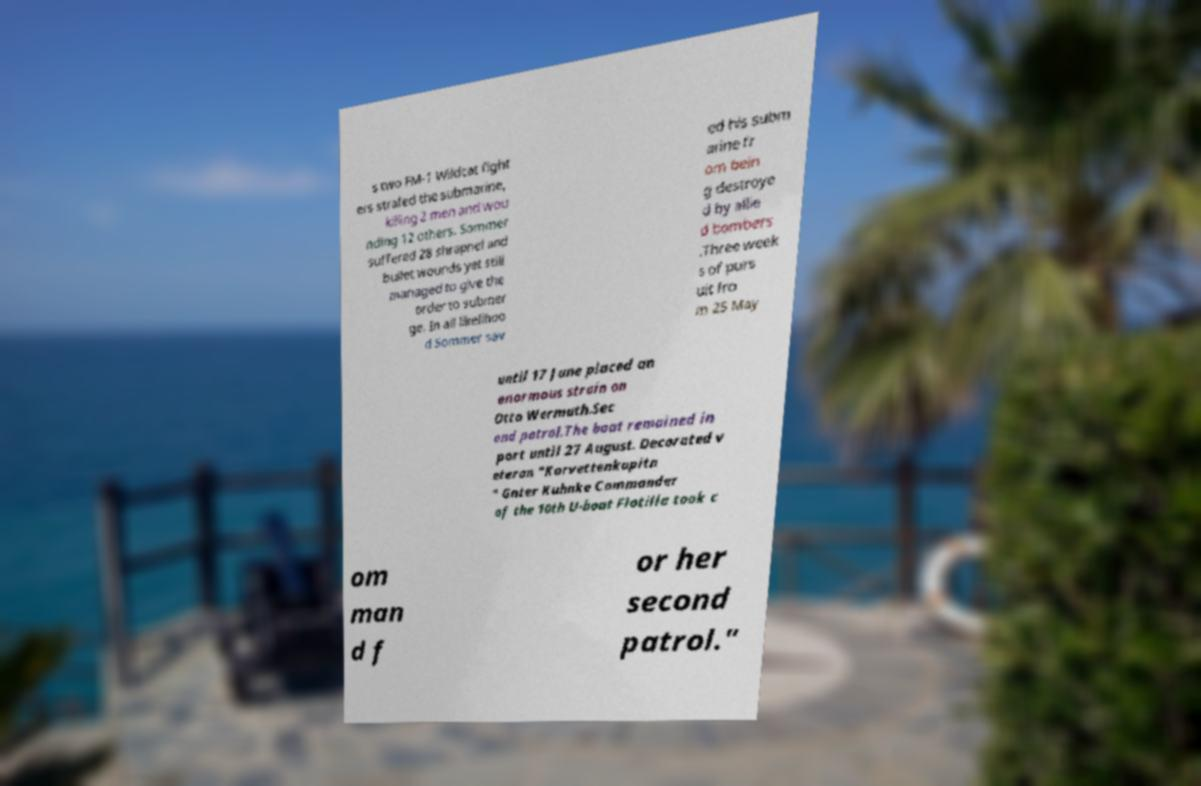Can you read and provide the text displayed in the image?This photo seems to have some interesting text. Can you extract and type it out for me? s two FM-1 Wildcat fight ers strafed the submarine, killing 2 men and wou nding 12 others. Sommer suffered 28 shrapnel and bullet wounds yet still managed to give the order to submer ge. In all likelihoo d Sommer sav ed his subm arine fr om bein g destroye d by allie d bombers .Three week s of purs uit fro m 25 May until 17 June placed an enormous strain on Otto Wermuth.Sec ond patrol.The boat remained in port until 27 August. Decorated v eteran "Korvettenkapitn " Gnter Kuhnke Commander of the 10th U-boat Flotilla took c om man d f or her second patrol." 